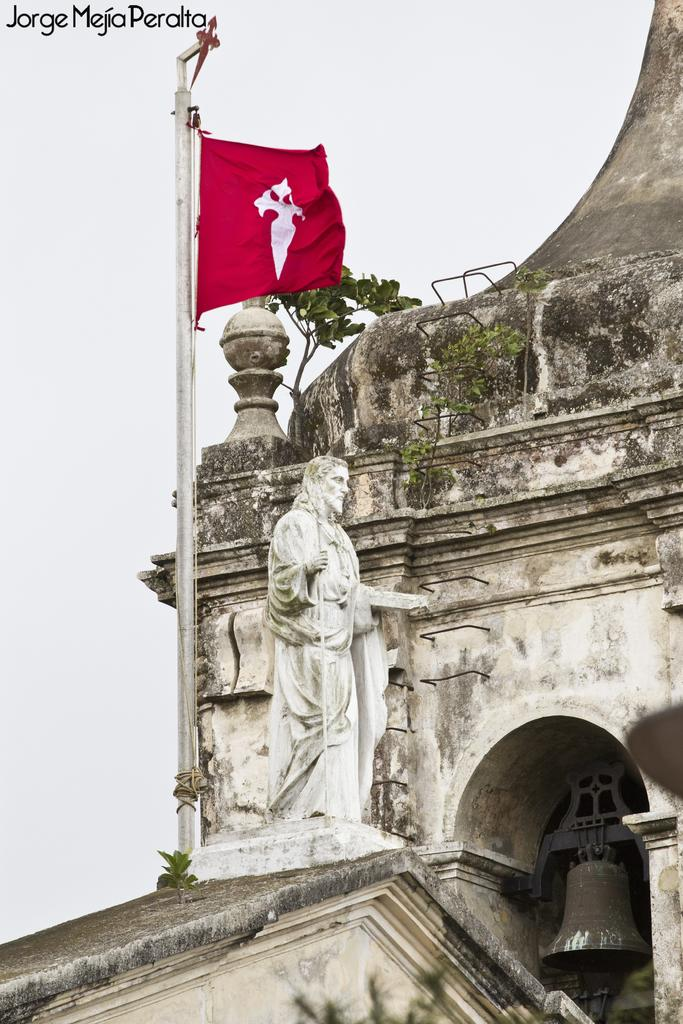What is the main subject in the image? There is a statue in the image. What else can be seen in the image besides the statue? There is a flag on a pole, a bell, a stone building, plants, and the sky visible in the background. Can you describe the flag in the image? The flag is on a pole in the image. What type of vegetation is present in the image? There are plants in the image. What is visible in the background of the image? The sky is visible in the background of the image. What type of letter is being delivered by the waves in the image? There are no waves or letters present in the image. 